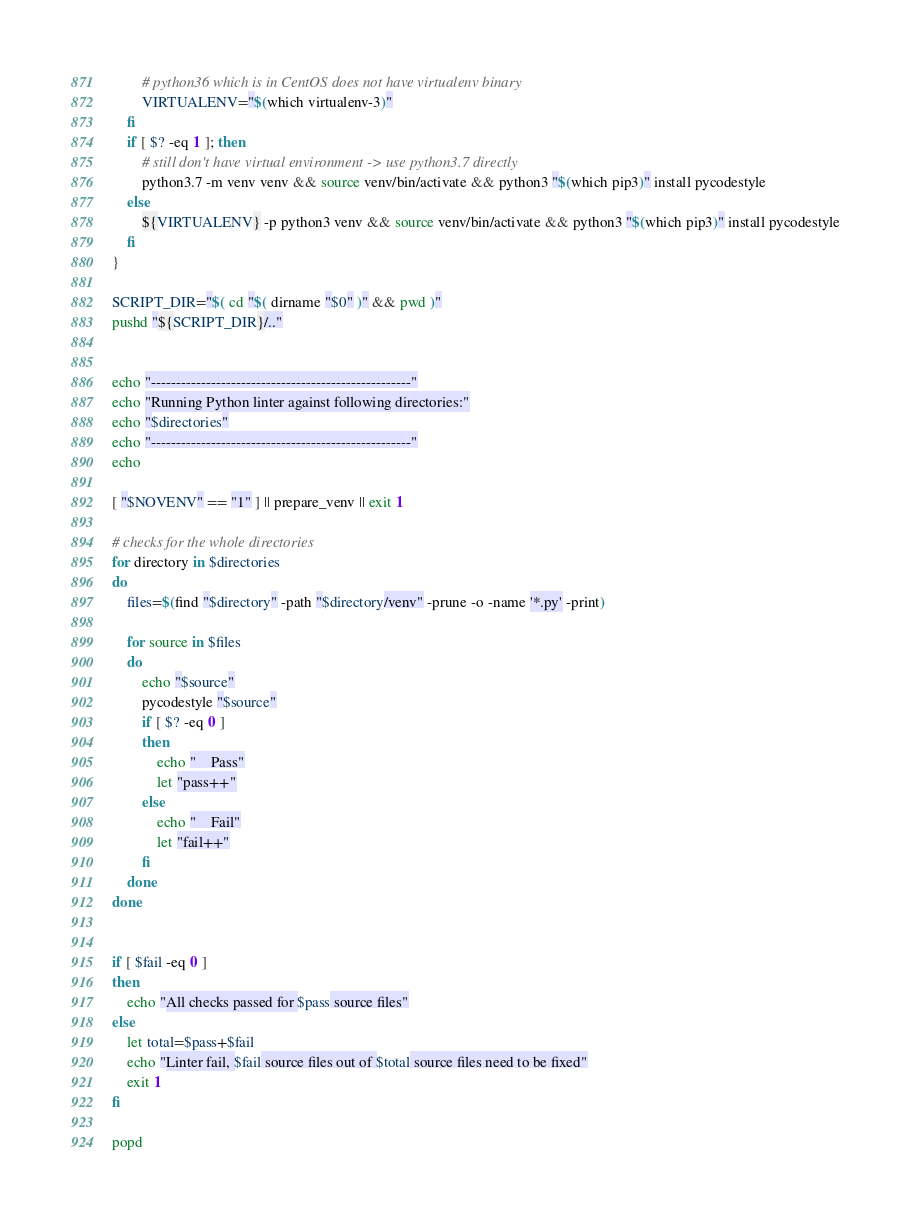<code> <loc_0><loc_0><loc_500><loc_500><_Bash_>        # python36 which is in CentOS does not have virtualenv binary
        VIRTUALENV="$(which virtualenv-3)"
    fi
    if [ $? -eq 1 ]; then
        # still don't have virtual environment -> use python3.7 directly
        python3.7 -m venv venv && source venv/bin/activate && python3 "$(which pip3)" install pycodestyle
    else
        ${VIRTUALENV} -p python3 venv && source venv/bin/activate && python3 "$(which pip3)" install pycodestyle
    fi
}

SCRIPT_DIR="$( cd "$( dirname "$0" )" && pwd )"
pushd "${SCRIPT_DIR}/.."


echo "----------------------------------------------------"
echo "Running Python linter against following directories:"
echo "$directories"
echo "----------------------------------------------------"
echo

[ "$NOVENV" == "1" ] || prepare_venv || exit 1

# checks for the whole directories
for directory in $directories
do
    files=$(find "$directory" -path "$directory/venv" -prune -o -name '*.py' -print)

    for source in $files
    do
        echo "$source"
        pycodestyle "$source"
        if [ $? -eq 0 ]
        then
            echo "    Pass"
            let "pass++"
        else
            echo "    Fail"
            let "fail++"
        fi
    done
done


if [ $fail -eq 0 ]
then
    echo "All checks passed for $pass source files"
else
    let total=$pass+$fail
    echo "Linter fail, $fail source files out of $total source files need to be fixed"
    exit 1
fi

popd
</code> 